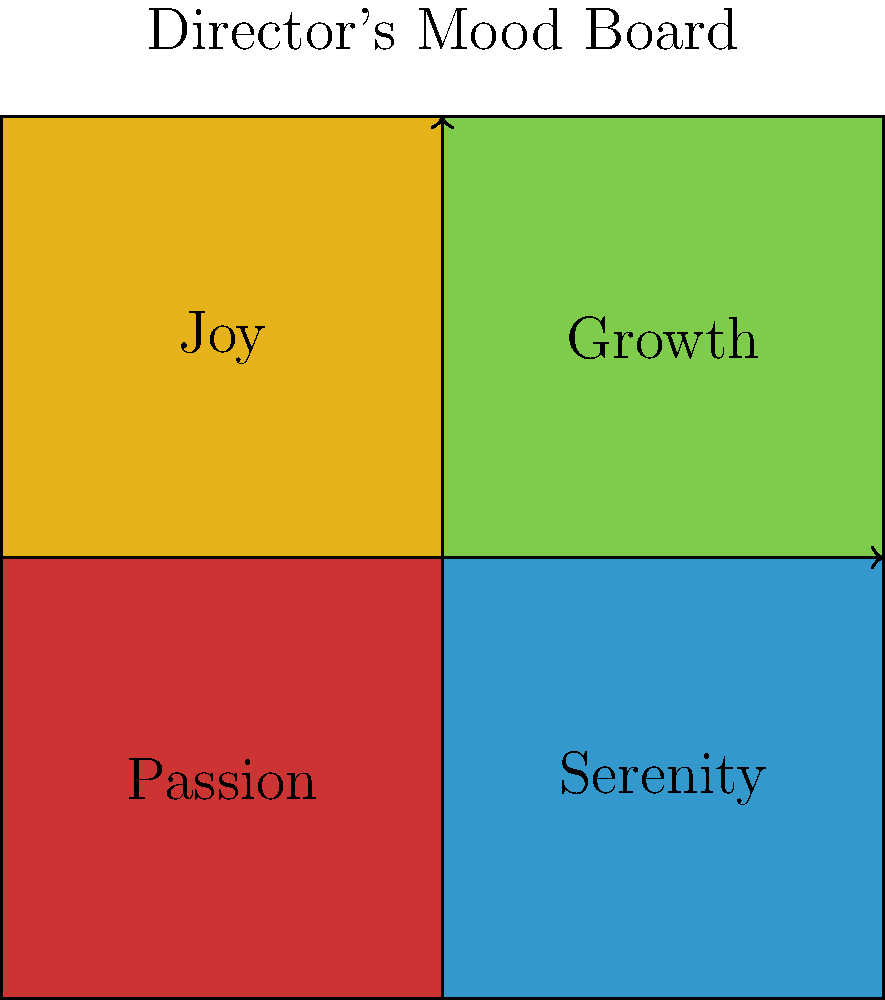Based on the director's abstract mood board for costume design, which emotion or concept should be most prominently reflected in the costumes for the protagonist's transformative scene? To answer this question, we need to analyze the mood board and its implications for costume design:

1. The mood board is divided into four quadrants, each representing a different emotion or concept:
   - Top-left (yellow): Joy
   - Top-right (green): Growth
   - Bottom-left (red): Passion
   - Bottom-right (blue): Serenity

2. The arrows connecting the quadrants suggest a progression or relationship between these concepts.

3. For a transformative scene, we should focus on the concept that best represents change or development.

4. Among the four concepts, "Growth" is the one that most directly implies transformation and character development.

5. The green color associated with "Growth" also symbolizes new beginnings, renewal, and progress in many cultural contexts.

6. Considering the unorthodox methods of the director, emphasizing "Growth" in the costume design would align with a bold, visually striking approach to representing the character's transformation.

Therefore, the costume design for the protagonist's transformative scene should most prominently reflect the concept of "Growth" as indicated in the top-right quadrant of the mood board.
Answer: Growth 